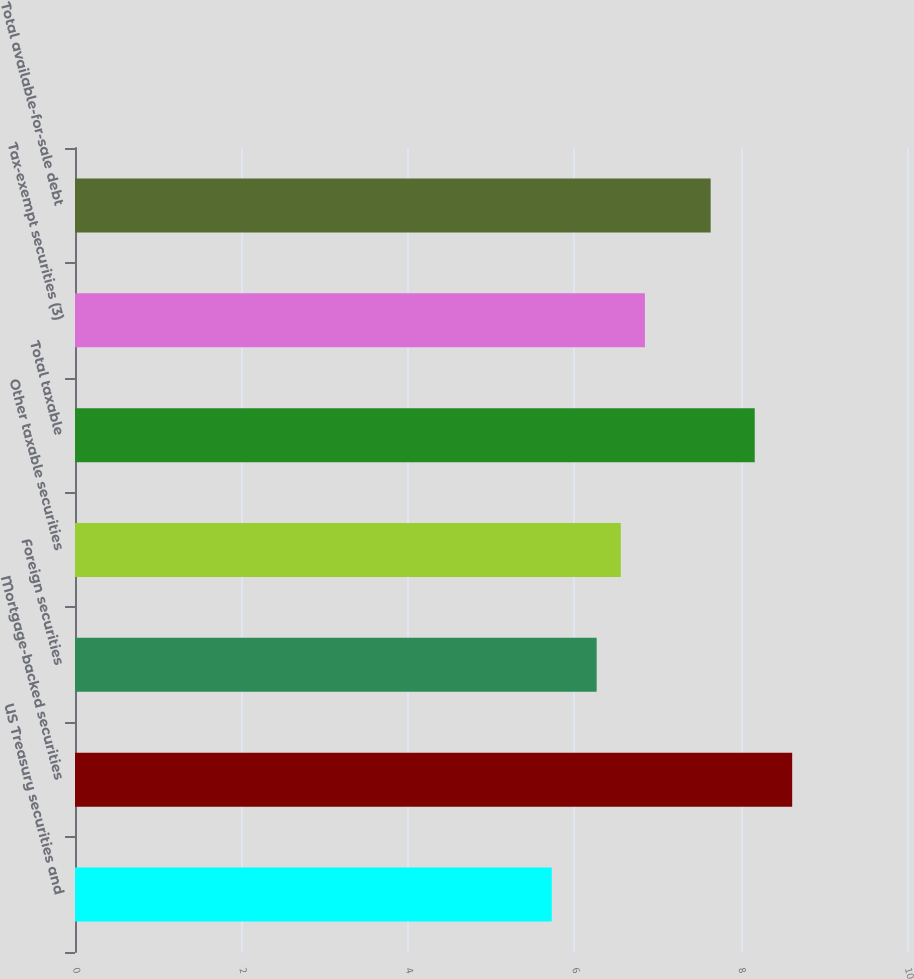Convert chart to OTSL. <chart><loc_0><loc_0><loc_500><loc_500><bar_chart><fcel>US Treasury securities and<fcel>Mortgage-backed securities<fcel>Foreign securities<fcel>Other taxable securities<fcel>Total taxable<fcel>Tax-exempt securities (3)<fcel>Total available-for-sale debt<nl><fcel>5.73<fcel>8.62<fcel>6.27<fcel>6.56<fcel>8.17<fcel>6.85<fcel>7.64<nl></chart> 